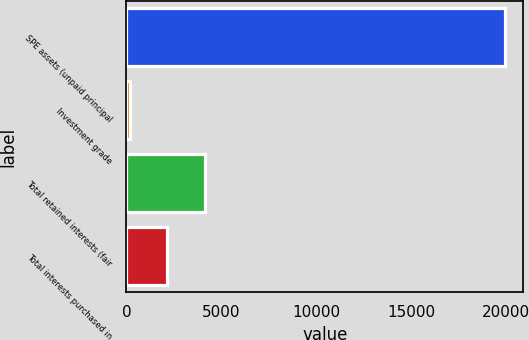Convert chart. <chart><loc_0><loc_0><loc_500><loc_500><bar_chart><fcel>SPE assets (unpaid principal<fcel>Investment grade<fcel>Total retained interests (fair<fcel>Total interests purchased in<nl><fcel>19921<fcel>178<fcel>4126.6<fcel>2152.3<nl></chart> 